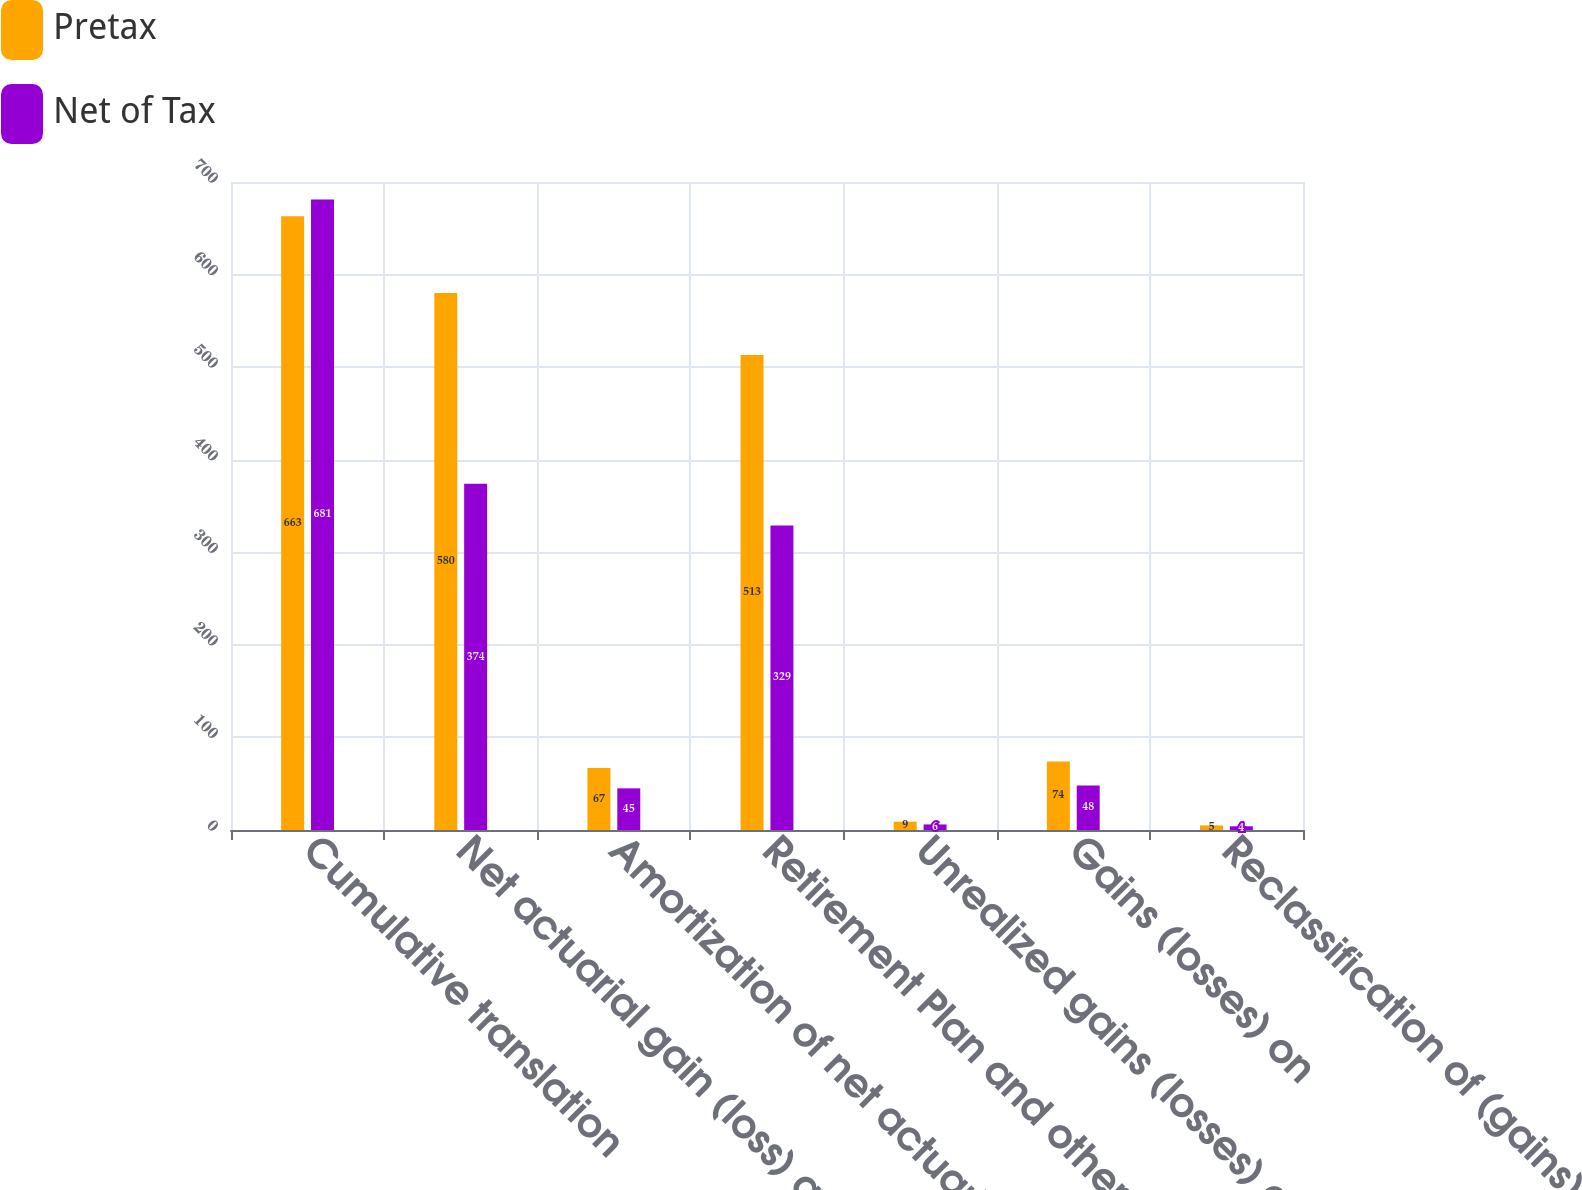Convert chart. <chart><loc_0><loc_0><loc_500><loc_500><stacked_bar_chart><ecel><fcel>Cumulative translation<fcel>Net actuarial gain (loss) and<fcel>Amortization of net actuarial<fcel>Retirement Plan and other<fcel>Unrealized gains (losses) on<fcel>Gains (losses) on<fcel>Reclassification of (gains)<nl><fcel>Pretax<fcel>663<fcel>580<fcel>67<fcel>513<fcel>9<fcel>74<fcel>5<nl><fcel>Net of Tax<fcel>681<fcel>374<fcel>45<fcel>329<fcel>6<fcel>48<fcel>4<nl></chart> 